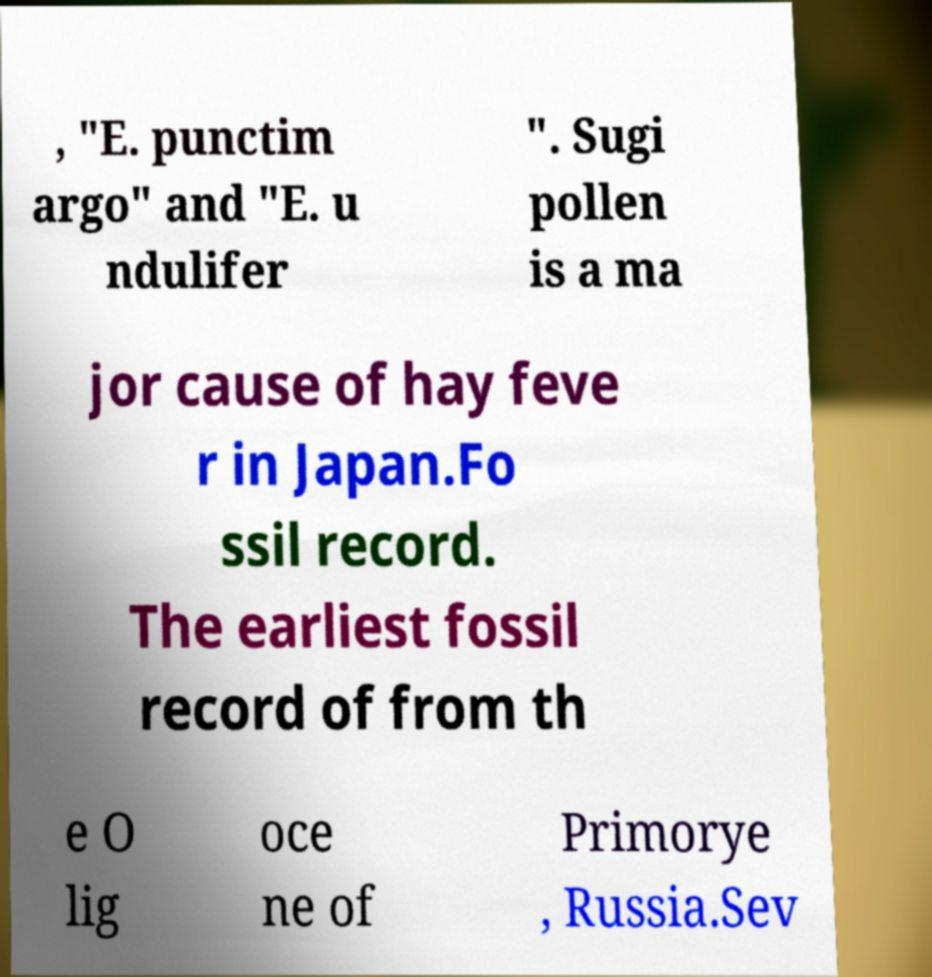Can you accurately transcribe the text from the provided image for me? , "E. punctim argo" and "E. u ndulifer ". Sugi pollen is a ma jor cause of hay feve r in Japan.Fo ssil record. The earliest fossil record of from th e O lig oce ne of Primorye , Russia.Sev 